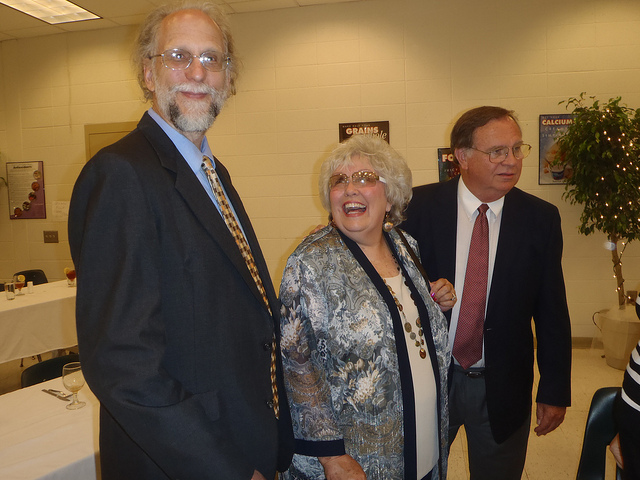Please transcribe the text in this image. GRAINS FO 